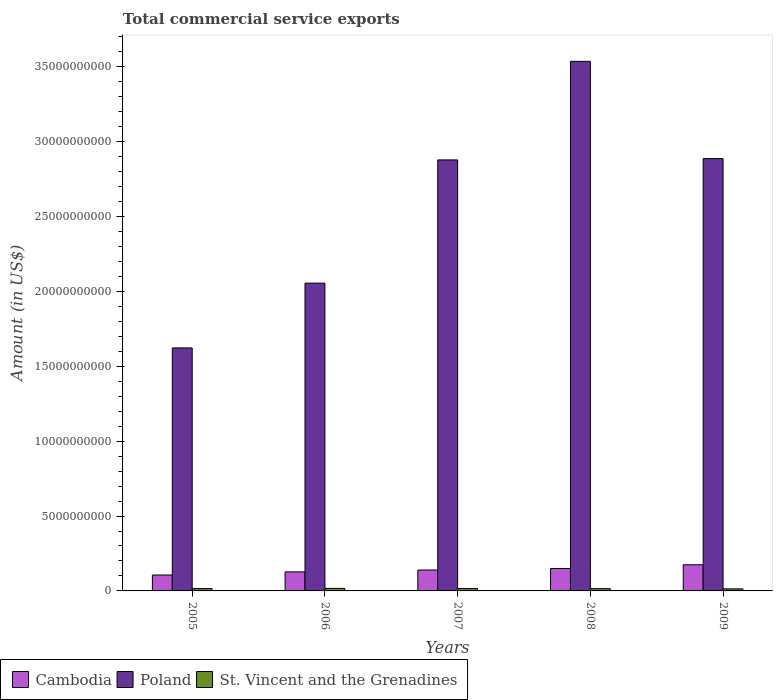How many groups of bars are there?
Give a very brief answer. 5. Are the number of bars on each tick of the X-axis equal?
Your answer should be compact. Yes. How many bars are there on the 3rd tick from the left?
Offer a terse response. 3. What is the total commercial service exports in Cambodia in 2005?
Your answer should be very brief. 1.06e+09. Across all years, what is the maximum total commercial service exports in St. Vincent and the Grenadines?
Keep it short and to the point. 1.69e+08. Across all years, what is the minimum total commercial service exports in Cambodia?
Give a very brief answer. 1.06e+09. In which year was the total commercial service exports in Poland minimum?
Make the answer very short. 2005. What is the total total commercial service exports in Poland in the graph?
Make the answer very short. 1.30e+11. What is the difference between the total commercial service exports in St. Vincent and the Grenadines in 2008 and that in 2009?
Make the answer very short. 1.39e+07. What is the difference between the total commercial service exports in Poland in 2007 and the total commercial service exports in Cambodia in 2009?
Your response must be concise. 2.70e+1. What is the average total commercial service exports in Cambodia per year?
Your answer should be compact. 1.39e+09. In the year 2007, what is the difference between the total commercial service exports in St. Vincent and the Grenadines and total commercial service exports in Cambodia?
Offer a terse response. -1.24e+09. In how many years, is the total commercial service exports in Cambodia greater than 21000000000 US$?
Make the answer very short. 0. What is the ratio of the total commercial service exports in St. Vincent and the Grenadines in 2008 to that in 2009?
Your response must be concise. 1.1. Is the difference between the total commercial service exports in St. Vincent and the Grenadines in 2006 and 2007 greater than the difference between the total commercial service exports in Cambodia in 2006 and 2007?
Keep it short and to the point. Yes. What is the difference between the highest and the second highest total commercial service exports in Poland?
Give a very brief answer. 6.49e+09. What is the difference between the highest and the lowest total commercial service exports in Cambodia?
Keep it short and to the point. 6.83e+08. Is the sum of the total commercial service exports in St. Vincent and the Grenadines in 2005 and 2007 greater than the maximum total commercial service exports in Poland across all years?
Offer a terse response. No. What does the 3rd bar from the left in 2007 represents?
Your answer should be very brief. St. Vincent and the Grenadines. What does the 2nd bar from the right in 2008 represents?
Keep it short and to the point. Poland. Is it the case that in every year, the sum of the total commercial service exports in Poland and total commercial service exports in St. Vincent and the Grenadines is greater than the total commercial service exports in Cambodia?
Provide a short and direct response. Yes. Are the values on the major ticks of Y-axis written in scientific E-notation?
Provide a succinct answer. No. Does the graph contain any zero values?
Keep it short and to the point. No. Where does the legend appear in the graph?
Give a very brief answer. Bottom left. How are the legend labels stacked?
Make the answer very short. Horizontal. What is the title of the graph?
Give a very brief answer. Total commercial service exports. What is the label or title of the X-axis?
Ensure brevity in your answer.  Years. What is the Amount (in US$) in Cambodia in 2005?
Keep it short and to the point. 1.06e+09. What is the Amount (in US$) in Poland in 2005?
Give a very brief answer. 1.62e+1. What is the Amount (in US$) in St. Vincent and the Grenadines in 2005?
Ensure brevity in your answer.  1.56e+08. What is the Amount (in US$) in Cambodia in 2006?
Your answer should be compact. 1.27e+09. What is the Amount (in US$) of Poland in 2006?
Ensure brevity in your answer.  2.05e+1. What is the Amount (in US$) in St. Vincent and the Grenadines in 2006?
Make the answer very short. 1.69e+08. What is the Amount (in US$) in Cambodia in 2007?
Provide a succinct answer. 1.40e+09. What is the Amount (in US$) of Poland in 2007?
Give a very brief answer. 2.88e+1. What is the Amount (in US$) in St. Vincent and the Grenadines in 2007?
Ensure brevity in your answer.  1.59e+08. What is the Amount (in US$) in Cambodia in 2008?
Make the answer very short. 1.49e+09. What is the Amount (in US$) in Poland in 2008?
Your answer should be very brief. 3.54e+1. What is the Amount (in US$) of St. Vincent and the Grenadines in 2008?
Your response must be concise. 1.51e+08. What is the Amount (in US$) of Cambodia in 2009?
Your answer should be compact. 1.75e+09. What is the Amount (in US$) in Poland in 2009?
Your response must be concise. 2.89e+1. What is the Amount (in US$) of St. Vincent and the Grenadines in 2009?
Give a very brief answer. 1.37e+08. Across all years, what is the maximum Amount (in US$) in Cambodia?
Offer a very short reply. 1.75e+09. Across all years, what is the maximum Amount (in US$) in Poland?
Offer a very short reply. 3.54e+1. Across all years, what is the maximum Amount (in US$) in St. Vincent and the Grenadines?
Provide a short and direct response. 1.69e+08. Across all years, what is the minimum Amount (in US$) in Cambodia?
Offer a very short reply. 1.06e+09. Across all years, what is the minimum Amount (in US$) of Poland?
Keep it short and to the point. 1.62e+1. Across all years, what is the minimum Amount (in US$) of St. Vincent and the Grenadines?
Give a very brief answer. 1.37e+08. What is the total Amount (in US$) in Cambodia in the graph?
Offer a very short reply. 6.97e+09. What is the total Amount (in US$) of Poland in the graph?
Keep it short and to the point. 1.30e+11. What is the total Amount (in US$) of St. Vincent and the Grenadines in the graph?
Offer a terse response. 7.71e+08. What is the difference between the Amount (in US$) in Cambodia in 2005 and that in 2006?
Provide a succinct answer. -2.08e+08. What is the difference between the Amount (in US$) of Poland in 2005 and that in 2006?
Provide a short and direct response. -4.32e+09. What is the difference between the Amount (in US$) in St. Vincent and the Grenadines in 2005 and that in 2006?
Offer a very short reply. -1.29e+07. What is the difference between the Amount (in US$) of Cambodia in 2005 and that in 2007?
Make the answer very short. -3.32e+08. What is the difference between the Amount (in US$) of Poland in 2005 and that in 2007?
Offer a very short reply. -1.26e+1. What is the difference between the Amount (in US$) in St. Vincent and the Grenadines in 2005 and that in 2007?
Offer a very short reply. -2.81e+06. What is the difference between the Amount (in US$) of Cambodia in 2005 and that in 2008?
Your answer should be compact. -4.31e+08. What is the difference between the Amount (in US$) in Poland in 2005 and that in 2008?
Provide a succinct answer. -1.91e+1. What is the difference between the Amount (in US$) of St. Vincent and the Grenadines in 2005 and that in 2008?
Your answer should be compact. 5.12e+06. What is the difference between the Amount (in US$) of Cambodia in 2005 and that in 2009?
Keep it short and to the point. -6.83e+08. What is the difference between the Amount (in US$) in Poland in 2005 and that in 2009?
Your response must be concise. -1.26e+1. What is the difference between the Amount (in US$) of St. Vincent and the Grenadines in 2005 and that in 2009?
Your answer should be compact. 1.90e+07. What is the difference between the Amount (in US$) in Cambodia in 2006 and that in 2007?
Your answer should be very brief. -1.24e+08. What is the difference between the Amount (in US$) of Poland in 2006 and that in 2007?
Offer a terse response. -8.22e+09. What is the difference between the Amount (in US$) of St. Vincent and the Grenadines in 2006 and that in 2007?
Your answer should be compact. 1.01e+07. What is the difference between the Amount (in US$) of Cambodia in 2006 and that in 2008?
Give a very brief answer. -2.23e+08. What is the difference between the Amount (in US$) in Poland in 2006 and that in 2008?
Give a very brief answer. -1.48e+1. What is the difference between the Amount (in US$) of St. Vincent and the Grenadines in 2006 and that in 2008?
Provide a succinct answer. 1.80e+07. What is the difference between the Amount (in US$) of Cambodia in 2006 and that in 2009?
Your response must be concise. -4.75e+08. What is the difference between the Amount (in US$) of Poland in 2006 and that in 2009?
Your answer should be very brief. -8.31e+09. What is the difference between the Amount (in US$) in St. Vincent and the Grenadines in 2006 and that in 2009?
Offer a very short reply. 3.19e+07. What is the difference between the Amount (in US$) of Cambodia in 2007 and that in 2008?
Provide a short and direct response. -9.91e+07. What is the difference between the Amount (in US$) of Poland in 2007 and that in 2008?
Your answer should be very brief. -6.58e+09. What is the difference between the Amount (in US$) of St. Vincent and the Grenadines in 2007 and that in 2008?
Provide a short and direct response. 7.93e+06. What is the difference between the Amount (in US$) in Cambodia in 2007 and that in 2009?
Ensure brevity in your answer.  -3.51e+08. What is the difference between the Amount (in US$) of Poland in 2007 and that in 2009?
Offer a very short reply. -8.80e+07. What is the difference between the Amount (in US$) of St. Vincent and the Grenadines in 2007 and that in 2009?
Offer a very short reply. 2.18e+07. What is the difference between the Amount (in US$) in Cambodia in 2008 and that in 2009?
Offer a terse response. -2.52e+08. What is the difference between the Amount (in US$) of Poland in 2008 and that in 2009?
Offer a very short reply. 6.49e+09. What is the difference between the Amount (in US$) in St. Vincent and the Grenadines in 2008 and that in 2009?
Your response must be concise. 1.39e+07. What is the difference between the Amount (in US$) of Cambodia in 2005 and the Amount (in US$) of Poland in 2006?
Provide a succinct answer. -1.95e+1. What is the difference between the Amount (in US$) of Cambodia in 2005 and the Amount (in US$) of St. Vincent and the Grenadines in 2006?
Make the answer very short. 8.95e+08. What is the difference between the Amount (in US$) of Poland in 2005 and the Amount (in US$) of St. Vincent and the Grenadines in 2006?
Offer a terse response. 1.61e+1. What is the difference between the Amount (in US$) in Cambodia in 2005 and the Amount (in US$) in Poland in 2007?
Keep it short and to the point. -2.77e+1. What is the difference between the Amount (in US$) in Cambodia in 2005 and the Amount (in US$) in St. Vincent and the Grenadines in 2007?
Your answer should be very brief. 9.05e+08. What is the difference between the Amount (in US$) of Poland in 2005 and the Amount (in US$) of St. Vincent and the Grenadines in 2007?
Your answer should be very brief. 1.61e+1. What is the difference between the Amount (in US$) in Cambodia in 2005 and the Amount (in US$) in Poland in 2008?
Ensure brevity in your answer.  -3.43e+1. What is the difference between the Amount (in US$) of Cambodia in 2005 and the Amount (in US$) of St. Vincent and the Grenadines in 2008?
Ensure brevity in your answer.  9.13e+08. What is the difference between the Amount (in US$) of Poland in 2005 and the Amount (in US$) of St. Vincent and the Grenadines in 2008?
Your answer should be compact. 1.61e+1. What is the difference between the Amount (in US$) of Cambodia in 2005 and the Amount (in US$) of Poland in 2009?
Your answer should be very brief. -2.78e+1. What is the difference between the Amount (in US$) in Cambodia in 2005 and the Amount (in US$) in St. Vincent and the Grenadines in 2009?
Offer a terse response. 9.27e+08. What is the difference between the Amount (in US$) of Poland in 2005 and the Amount (in US$) of St. Vincent and the Grenadines in 2009?
Offer a very short reply. 1.61e+1. What is the difference between the Amount (in US$) of Cambodia in 2006 and the Amount (in US$) of Poland in 2007?
Your answer should be very brief. -2.75e+1. What is the difference between the Amount (in US$) in Cambodia in 2006 and the Amount (in US$) in St. Vincent and the Grenadines in 2007?
Provide a short and direct response. 1.11e+09. What is the difference between the Amount (in US$) of Poland in 2006 and the Amount (in US$) of St. Vincent and the Grenadines in 2007?
Provide a succinct answer. 2.04e+1. What is the difference between the Amount (in US$) of Cambodia in 2006 and the Amount (in US$) of Poland in 2008?
Offer a terse response. -3.41e+1. What is the difference between the Amount (in US$) in Cambodia in 2006 and the Amount (in US$) in St. Vincent and the Grenadines in 2008?
Offer a very short reply. 1.12e+09. What is the difference between the Amount (in US$) of Poland in 2006 and the Amount (in US$) of St. Vincent and the Grenadines in 2008?
Make the answer very short. 2.04e+1. What is the difference between the Amount (in US$) in Cambodia in 2006 and the Amount (in US$) in Poland in 2009?
Your answer should be very brief. -2.76e+1. What is the difference between the Amount (in US$) of Cambodia in 2006 and the Amount (in US$) of St. Vincent and the Grenadines in 2009?
Offer a very short reply. 1.13e+09. What is the difference between the Amount (in US$) in Poland in 2006 and the Amount (in US$) in St. Vincent and the Grenadines in 2009?
Offer a very short reply. 2.04e+1. What is the difference between the Amount (in US$) in Cambodia in 2007 and the Amount (in US$) in Poland in 2008?
Your answer should be compact. -3.40e+1. What is the difference between the Amount (in US$) in Cambodia in 2007 and the Amount (in US$) in St. Vincent and the Grenadines in 2008?
Your answer should be compact. 1.24e+09. What is the difference between the Amount (in US$) of Poland in 2007 and the Amount (in US$) of St. Vincent and the Grenadines in 2008?
Make the answer very short. 2.86e+1. What is the difference between the Amount (in US$) in Cambodia in 2007 and the Amount (in US$) in Poland in 2009?
Keep it short and to the point. -2.75e+1. What is the difference between the Amount (in US$) in Cambodia in 2007 and the Amount (in US$) in St. Vincent and the Grenadines in 2009?
Your answer should be very brief. 1.26e+09. What is the difference between the Amount (in US$) of Poland in 2007 and the Amount (in US$) of St. Vincent and the Grenadines in 2009?
Provide a succinct answer. 2.86e+1. What is the difference between the Amount (in US$) in Cambodia in 2008 and the Amount (in US$) in Poland in 2009?
Offer a very short reply. -2.74e+1. What is the difference between the Amount (in US$) of Cambodia in 2008 and the Amount (in US$) of St. Vincent and the Grenadines in 2009?
Ensure brevity in your answer.  1.36e+09. What is the difference between the Amount (in US$) in Poland in 2008 and the Amount (in US$) in St. Vincent and the Grenadines in 2009?
Make the answer very short. 3.52e+1. What is the average Amount (in US$) of Cambodia per year?
Your answer should be compact. 1.39e+09. What is the average Amount (in US$) of Poland per year?
Your response must be concise. 2.60e+1. What is the average Amount (in US$) in St. Vincent and the Grenadines per year?
Make the answer very short. 1.54e+08. In the year 2005, what is the difference between the Amount (in US$) in Cambodia and Amount (in US$) in Poland?
Your answer should be compact. -1.52e+1. In the year 2005, what is the difference between the Amount (in US$) in Cambodia and Amount (in US$) in St. Vincent and the Grenadines?
Your response must be concise. 9.08e+08. In the year 2005, what is the difference between the Amount (in US$) of Poland and Amount (in US$) of St. Vincent and the Grenadines?
Your answer should be very brief. 1.61e+1. In the year 2006, what is the difference between the Amount (in US$) in Cambodia and Amount (in US$) in Poland?
Your answer should be very brief. -1.93e+1. In the year 2006, what is the difference between the Amount (in US$) in Cambodia and Amount (in US$) in St. Vincent and the Grenadines?
Offer a very short reply. 1.10e+09. In the year 2006, what is the difference between the Amount (in US$) in Poland and Amount (in US$) in St. Vincent and the Grenadines?
Make the answer very short. 2.04e+1. In the year 2007, what is the difference between the Amount (in US$) of Cambodia and Amount (in US$) of Poland?
Provide a short and direct response. -2.74e+1. In the year 2007, what is the difference between the Amount (in US$) of Cambodia and Amount (in US$) of St. Vincent and the Grenadines?
Your answer should be very brief. 1.24e+09. In the year 2007, what is the difference between the Amount (in US$) of Poland and Amount (in US$) of St. Vincent and the Grenadines?
Provide a succinct answer. 2.86e+1. In the year 2008, what is the difference between the Amount (in US$) of Cambodia and Amount (in US$) of Poland?
Your answer should be compact. -3.39e+1. In the year 2008, what is the difference between the Amount (in US$) in Cambodia and Amount (in US$) in St. Vincent and the Grenadines?
Your answer should be very brief. 1.34e+09. In the year 2008, what is the difference between the Amount (in US$) of Poland and Amount (in US$) of St. Vincent and the Grenadines?
Offer a very short reply. 3.52e+1. In the year 2009, what is the difference between the Amount (in US$) of Cambodia and Amount (in US$) of Poland?
Offer a terse response. -2.71e+1. In the year 2009, what is the difference between the Amount (in US$) in Cambodia and Amount (in US$) in St. Vincent and the Grenadines?
Provide a succinct answer. 1.61e+09. In the year 2009, what is the difference between the Amount (in US$) in Poland and Amount (in US$) in St. Vincent and the Grenadines?
Ensure brevity in your answer.  2.87e+1. What is the ratio of the Amount (in US$) in Cambodia in 2005 to that in 2006?
Your answer should be compact. 0.84. What is the ratio of the Amount (in US$) in Poland in 2005 to that in 2006?
Offer a very short reply. 0.79. What is the ratio of the Amount (in US$) of St. Vincent and the Grenadines in 2005 to that in 2006?
Keep it short and to the point. 0.92. What is the ratio of the Amount (in US$) in Cambodia in 2005 to that in 2007?
Keep it short and to the point. 0.76. What is the ratio of the Amount (in US$) of Poland in 2005 to that in 2007?
Offer a terse response. 0.56. What is the ratio of the Amount (in US$) in St. Vincent and the Grenadines in 2005 to that in 2007?
Ensure brevity in your answer.  0.98. What is the ratio of the Amount (in US$) in Cambodia in 2005 to that in 2008?
Make the answer very short. 0.71. What is the ratio of the Amount (in US$) in Poland in 2005 to that in 2008?
Offer a very short reply. 0.46. What is the ratio of the Amount (in US$) in St. Vincent and the Grenadines in 2005 to that in 2008?
Your answer should be compact. 1.03. What is the ratio of the Amount (in US$) of Cambodia in 2005 to that in 2009?
Your response must be concise. 0.61. What is the ratio of the Amount (in US$) of Poland in 2005 to that in 2009?
Give a very brief answer. 0.56. What is the ratio of the Amount (in US$) of St. Vincent and the Grenadines in 2005 to that in 2009?
Provide a succinct answer. 1.14. What is the ratio of the Amount (in US$) in Cambodia in 2006 to that in 2007?
Your answer should be compact. 0.91. What is the ratio of the Amount (in US$) of Poland in 2006 to that in 2007?
Keep it short and to the point. 0.71. What is the ratio of the Amount (in US$) of St. Vincent and the Grenadines in 2006 to that in 2007?
Provide a short and direct response. 1.06. What is the ratio of the Amount (in US$) in Cambodia in 2006 to that in 2008?
Keep it short and to the point. 0.85. What is the ratio of the Amount (in US$) in Poland in 2006 to that in 2008?
Offer a terse response. 0.58. What is the ratio of the Amount (in US$) of St. Vincent and the Grenadines in 2006 to that in 2008?
Offer a terse response. 1.12. What is the ratio of the Amount (in US$) in Cambodia in 2006 to that in 2009?
Offer a very short reply. 0.73. What is the ratio of the Amount (in US$) in Poland in 2006 to that in 2009?
Your answer should be compact. 0.71. What is the ratio of the Amount (in US$) of St. Vincent and the Grenadines in 2006 to that in 2009?
Ensure brevity in your answer.  1.23. What is the ratio of the Amount (in US$) of Cambodia in 2007 to that in 2008?
Offer a terse response. 0.93. What is the ratio of the Amount (in US$) of Poland in 2007 to that in 2008?
Provide a succinct answer. 0.81. What is the ratio of the Amount (in US$) of St. Vincent and the Grenadines in 2007 to that in 2008?
Make the answer very short. 1.05. What is the ratio of the Amount (in US$) in Cambodia in 2007 to that in 2009?
Provide a short and direct response. 0.8. What is the ratio of the Amount (in US$) of Poland in 2007 to that in 2009?
Make the answer very short. 1. What is the ratio of the Amount (in US$) of St. Vincent and the Grenadines in 2007 to that in 2009?
Your response must be concise. 1.16. What is the ratio of the Amount (in US$) of Cambodia in 2008 to that in 2009?
Provide a succinct answer. 0.86. What is the ratio of the Amount (in US$) of Poland in 2008 to that in 2009?
Provide a succinct answer. 1.22. What is the ratio of the Amount (in US$) of St. Vincent and the Grenadines in 2008 to that in 2009?
Provide a succinct answer. 1.1. What is the difference between the highest and the second highest Amount (in US$) of Cambodia?
Provide a short and direct response. 2.52e+08. What is the difference between the highest and the second highest Amount (in US$) of Poland?
Keep it short and to the point. 6.49e+09. What is the difference between the highest and the second highest Amount (in US$) of St. Vincent and the Grenadines?
Make the answer very short. 1.01e+07. What is the difference between the highest and the lowest Amount (in US$) in Cambodia?
Your answer should be very brief. 6.83e+08. What is the difference between the highest and the lowest Amount (in US$) in Poland?
Provide a short and direct response. 1.91e+1. What is the difference between the highest and the lowest Amount (in US$) in St. Vincent and the Grenadines?
Offer a very short reply. 3.19e+07. 